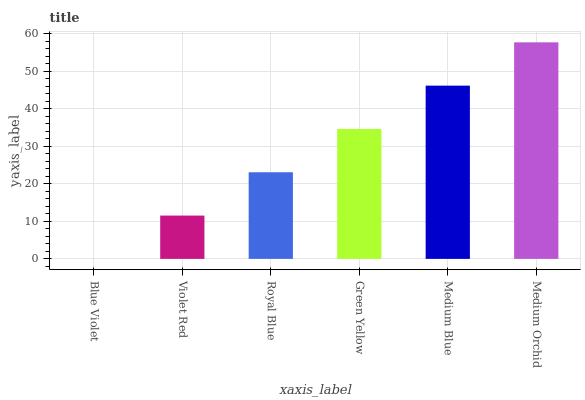Is Blue Violet the minimum?
Answer yes or no. Yes. Is Medium Orchid the maximum?
Answer yes or no. Yes. Is Violet Red the minimum?
Answer yes or no. No. Is Violet Red the maximum?
Answer yes or no. No. Is Violet Red greater than Blue Violet?
Answer yes or no. Yes. Is Blue Violet less than Violet Red?
Answer yes or no. Yes. Is Blue Violet greater than Violet Red?
Answer yes or no. No. Is Violet Red less than Blue Violet?
Answer yes or no. No. Is Green Yellow the high median?
Answer yes or no. Yes. Is Royal Blue the low median?
Answer yes or no. Yes. Is Blue Violet the high median?
Answer yes or no. No. Is Green Yellow the low median?
Answer yes or no. No. 